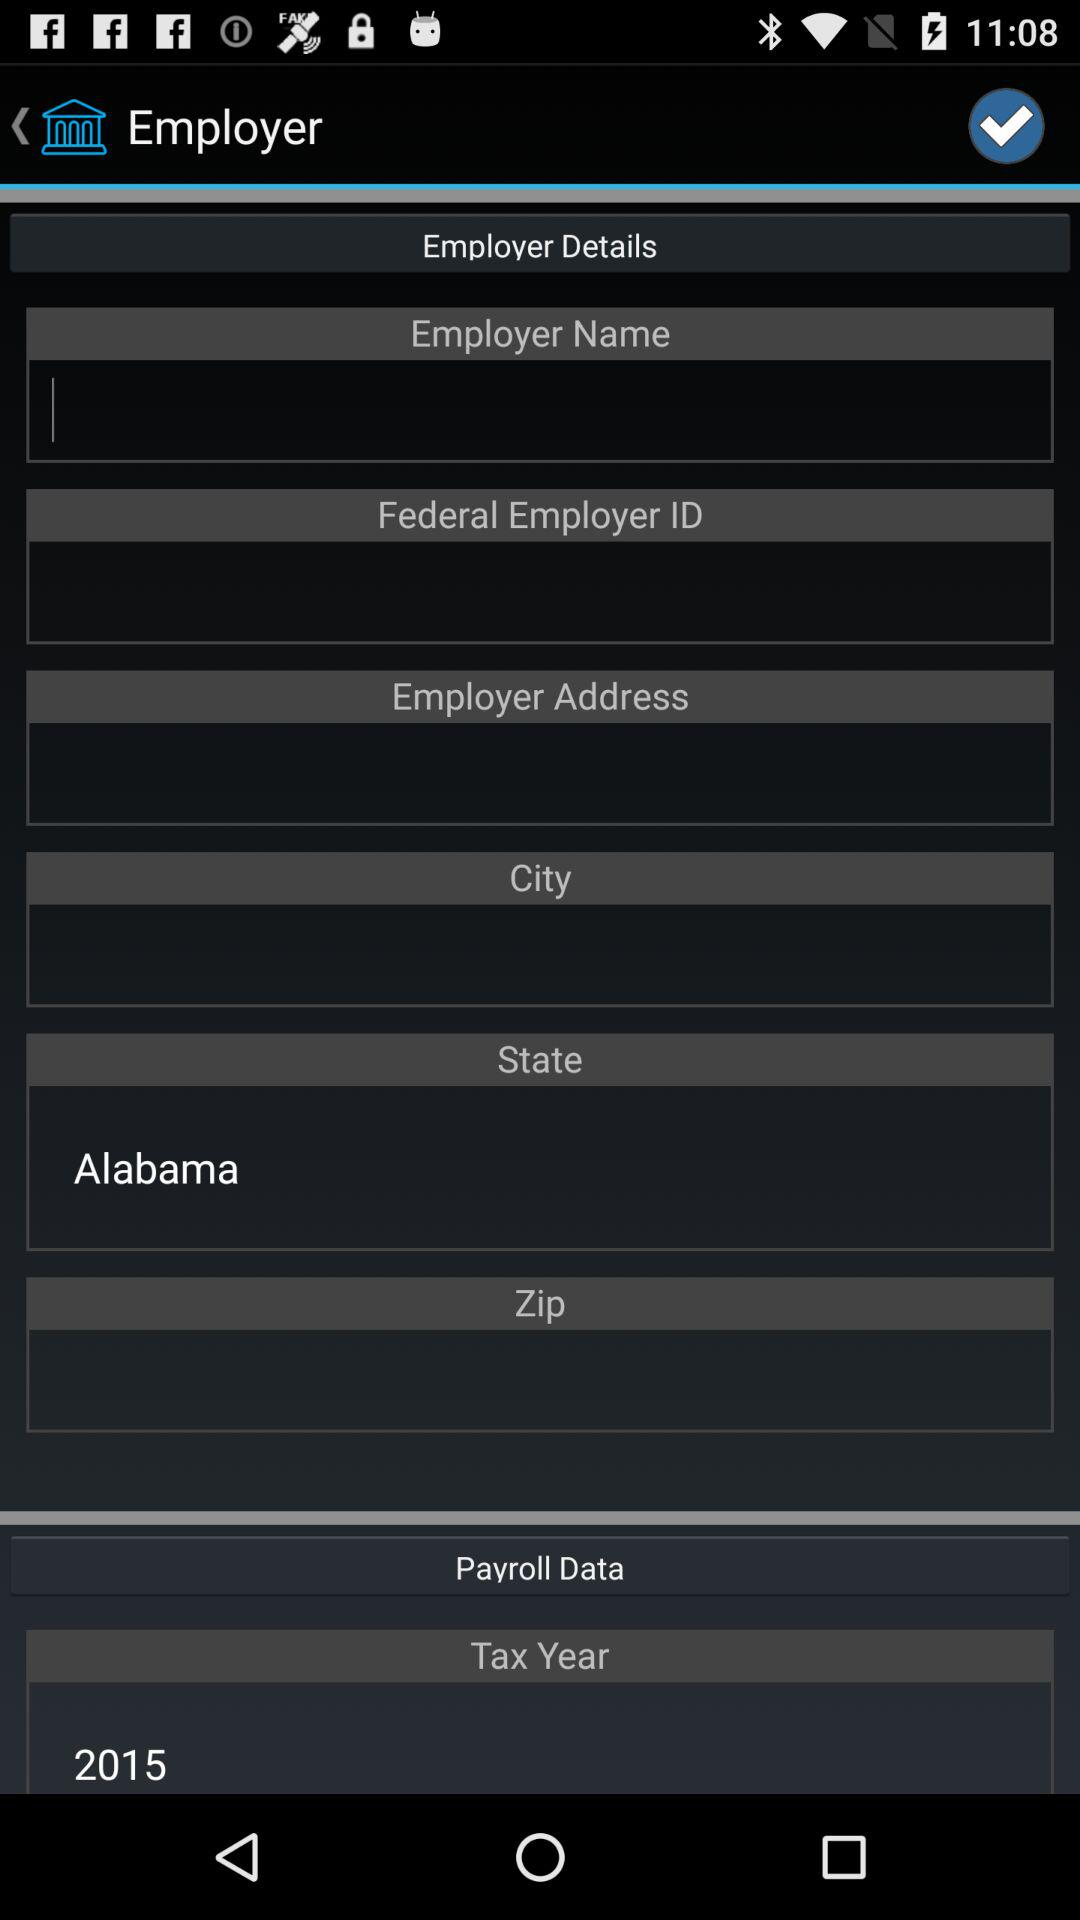What is the selected tax year? The selected tax year is 2015. 